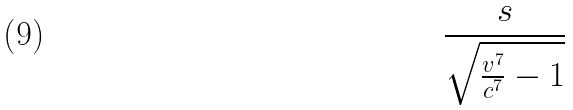<formula> <loc_0><loc_0><loc_500><loc_500>\frac { s } { \sqrt { \frac { v ^ { 7 } } { c ^ { 7 } } - 1 } }</formula> 